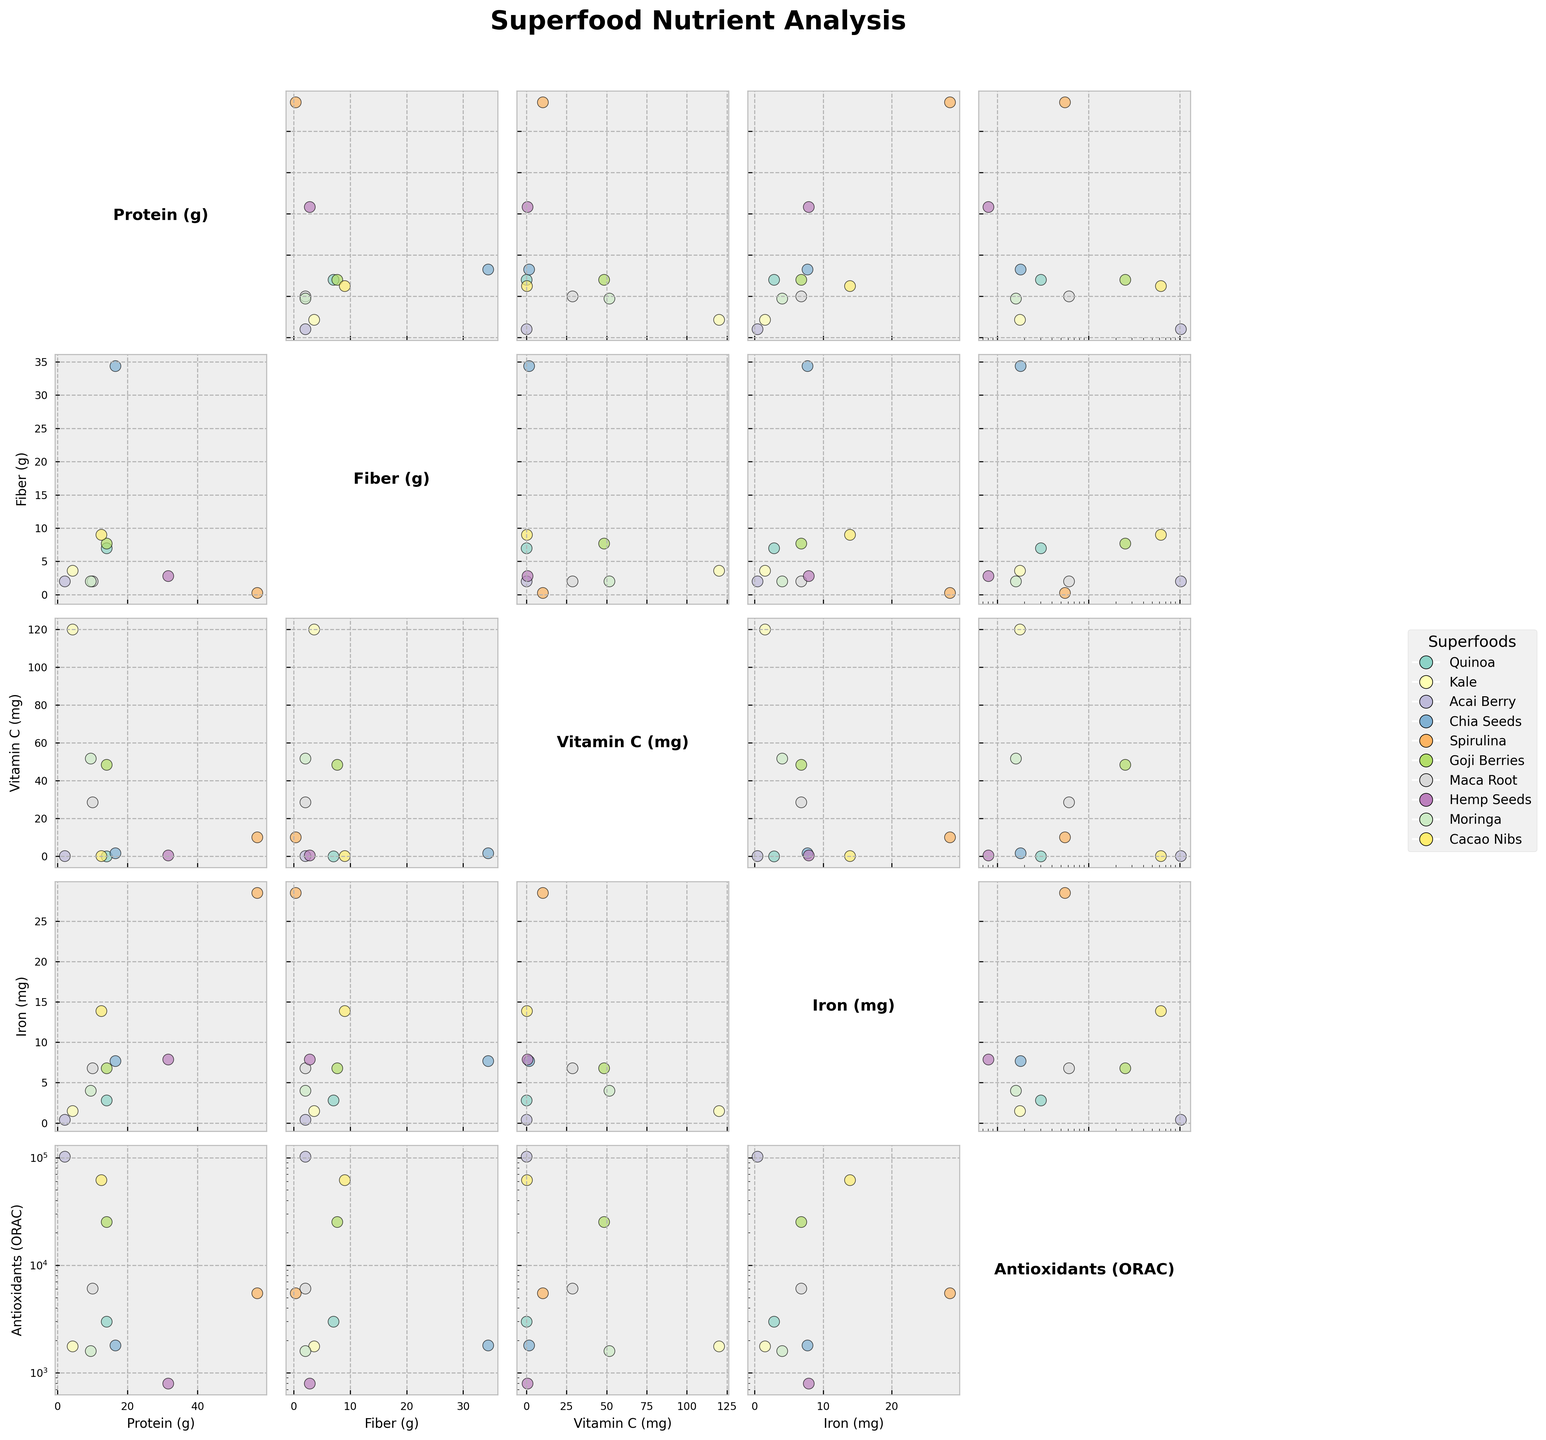What is the title of the figure? The title of the figure is positioned at the top of the plot, which is usually bold and in a larger font to make it stand out.
Answer: Superfood Nutrient Analysis How many superfoods are analyzed in the scatterplot matrix? Count the number of unique superfoods listed in the legend or on the plot.
Answer: 10 Which superfood has the highest protein content? Look at the scatterplot matrix for the highest value in the "Protein (g)" column.
Answer: Spirulina Is there a relationship between fiber and protein content in superfoods? Examine the scatterplot of "Fiber (g)" vs. "Protein (g)" to see if there is a pattern or trend.
Answer: No clear relationship Which superfood shows a high amount of antioxidants (ORAC) but low Vitamin C? Identify the superfoods with high "Antioxidants (ORAC)" values and cross-check with their "Vitamin C (mg)" values.
Answer: Acai Berry How does the iron content in Spirulina compare to other superfoods? Look at the "Iron (mg)" column in the scatterplot matrix and compare Spirulina's position with other superfoods.
Answer: Spirulina has the highest iron content What is the general trend between antioxidants (ORAC) and protein content among these superfoods? Check the scatterplot of "Antioxidants (ORAC)" vs. "Protein (g)" for any emerging trend.
Answer: No clear trend Which superfood has a balance of high protein and high fiber content? Identify superfoods that have high values in both "Protein (g)" and "Fiber (g)" dimensions.
Answer: Chia Seeds Does any superfood have both high Vitamin C and high antioxidant (ORAC) values? Look for superfoods that are high in both "Vitamin C (mg)" and "Antioxidants (ORAC)" values in their respective scatterplots.
Answer: No Which superfood has a significantly low value of all nutrients compared to others? Observe the scatterplot matrix for any superfood consistently plotted at low positions across all variables.
Answer: None 